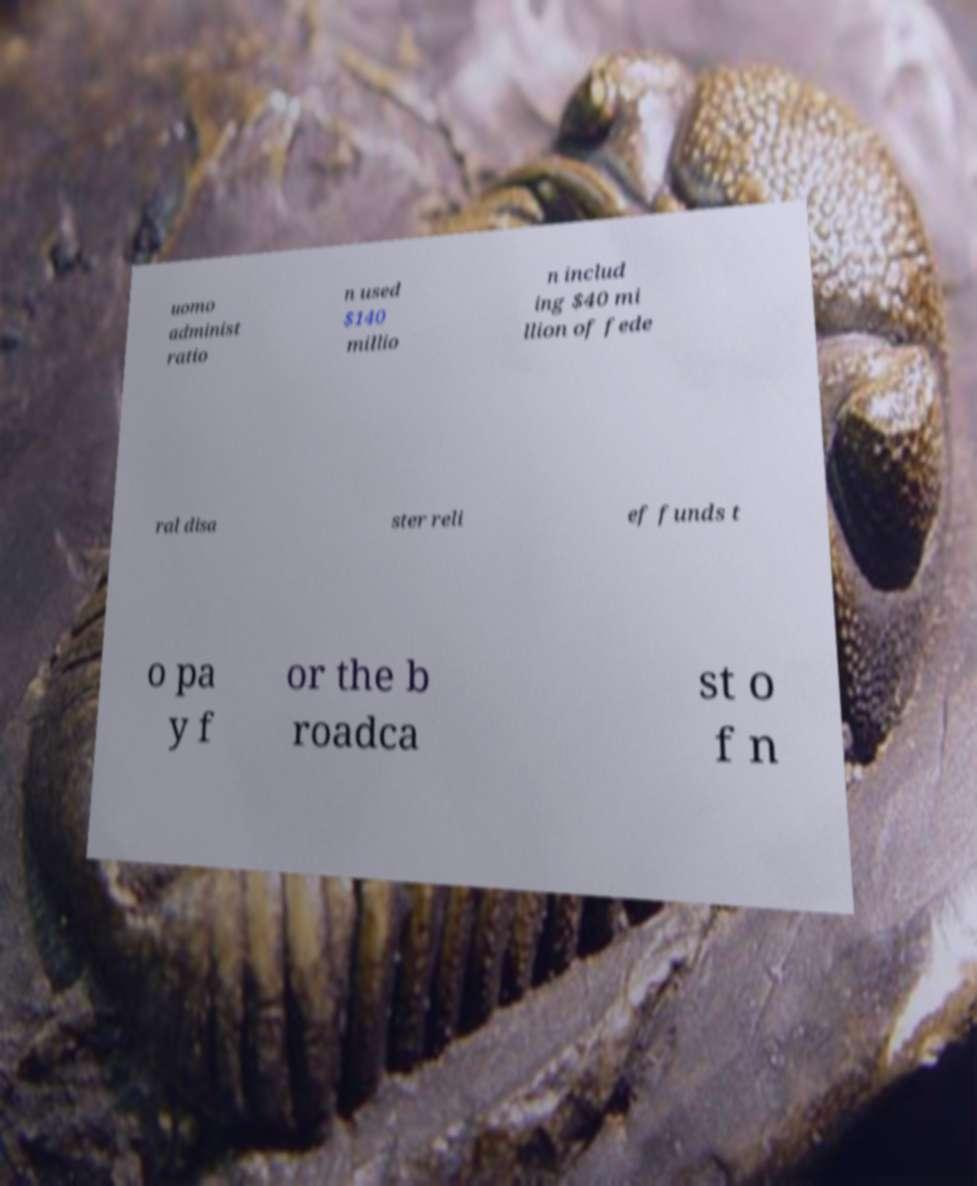What messages or text are displayed in this image? I need them in a readable, typed format. uomo administ ratio n used $140 millio n includ ing $40 mi llion of fede ral disa ster reli ef funds t o pa y f or the b roadca st o f n 